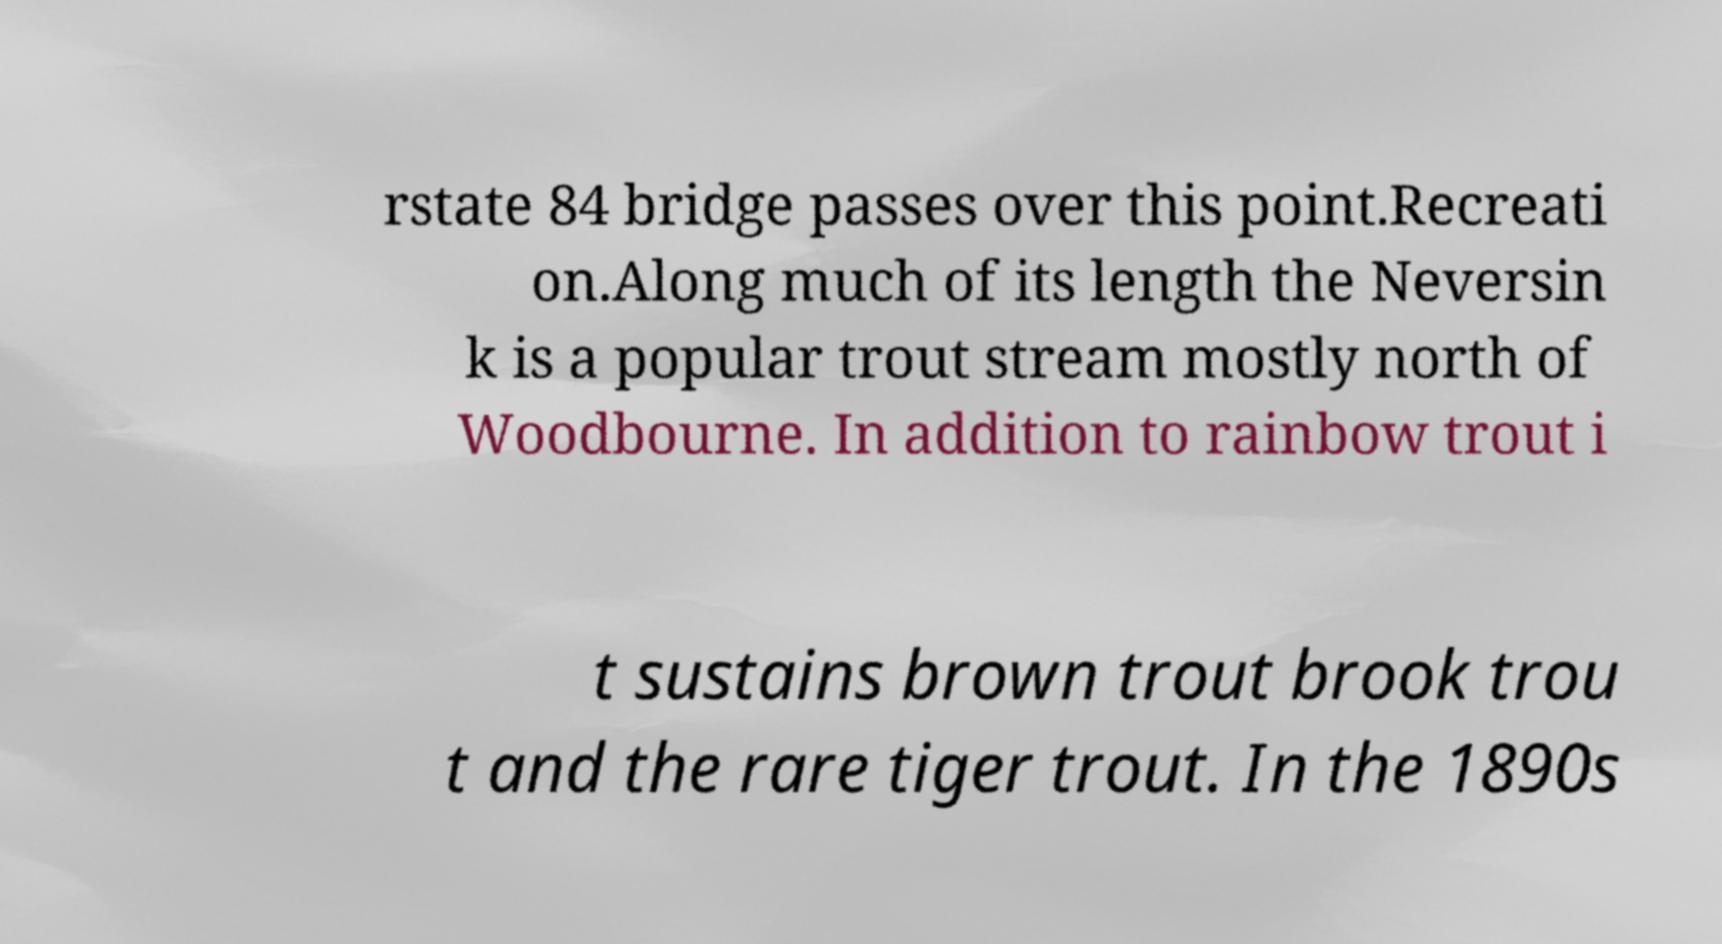What messages or text are displayed in this image? I need them in a readable, typed format. rstate 84 bridge passes over this point.Recreati on.Along much of its length the Neversin k is a popular trout stream mostly north of Woodbourne. In addition to rainbow trout i t sustains brown trout brook trou t and the rare tiger trout. In the 1890s 